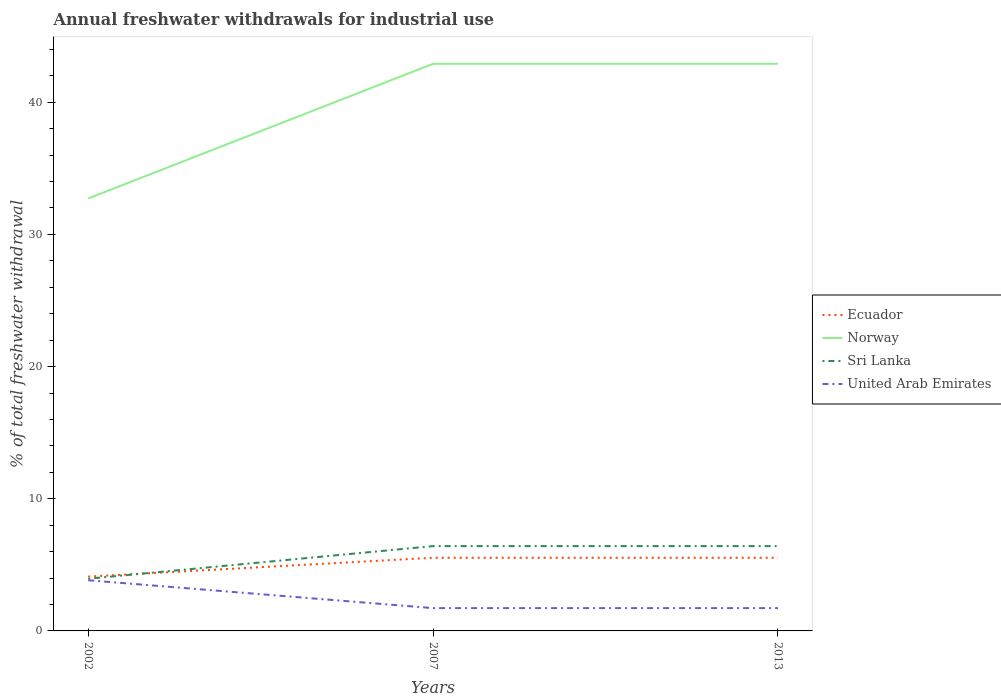How many different coloured lines are there?
Keep it short and to the point. 4. Is the number of lines equal to the number of legend labels?
Provide a short and direct response. Yes. Across all years, what is the maximum total annual withdrawals from freshwater in Norway?
Make the answer very short. 32.72. In which year was the total annual withdrawals from freshwater in Norway maximum?
Your answer should be very brief. 2002. What is the total total annual withdrawals from freshwater in Norway in the graph?
Your answer should be compact. 0. What is the difference between the highest and the second highest total annual withdrawals from freshwater in Norway?
Your response must be concise. 10.19. What is the difference between two consecutive major ticks on the Y-axis?
Keep it short and to the point. 10. Does the graph contain any zero values?
Provide a succinct answer. No. How many legend labels are there?
Provide a succinct answer. 4. How are the legend labels stacked?
Provide a succinct answer. Vertical. What is the title of the graph?
Your answer should be very brief. Annual freshwater withdrawals for industrial use. What is the label or title of the Y-axis?
Ensure brevity in your answer.  % of total freshwater withdrawal. What is the % of total freshwater withdrawal in Ecuador in 2002?
Offer a terse response. 4.11. What is the % of total freshwater withdrawal in Norway in 2002?
Ensure brevity in your answer.  32.72. What is the % of total freshwater withdrawal of Sri Lanka in 2002?
Offer a terse response. 3.95. What is the % of total freshwater withdrawal of United Arab Emirates in 2002?
Offer a terse response. 3.83. What is the % of total freshwater withdrawal of Ecuador in 2007?
Provide a short and direct response. 5.54. What is the % of total freshwater withdrawal in Norway in 2007?
Keep it short and to the point. 42.91. What is the % of total freshwater withdrawal in Sri Lanka in 2007?
Your response must be concise. 6.42. What is the % of total freshwater withdrawal of United Arab Emirates in 2007?
Make the answer very short. 1.73. What is the % of total freshwater withdrawal in Ecuador in 2013?
Offer a very short reply. 5.54. What is the % of total freshwater withdrawal of Norway in 2013?
Give a very brief answer. 42.91. What is the % of total freshwater withdrawal in Sri Lanka in 2013?
Provide a short and direct response. 6.42. What is the % of total freshwater withdrawal in United Arab Emirates in 2013?
Ensure brevity in your answer.  1.73. Across all years, what is the maximum % of total freshwater withdrawal in Ecuador?
Offer a very short reply. 5.54. Across all years, what is the maximum % of total freshwater withdrawal of Norway?
Offer a very short reply. 42.91. Across all years, what is the maximum % of total freshwater withdrawal in Sri Lanka?
Offer a very short reply. 6.42. Across all years, what is the maximum % of total freshwater withdrawal of United Arab Emirates?
Provide a succinct answer. 3.83. Across all years, what is the minimum % of total freshwater withdrawal of Ecuador?
Offer a terse response. 4.11. Across all years, what is the minimum % of total freshwater withdrawal in Norway?
Give a very brief answer. 32.72. Across all years, what is the minimum % of total freshwater withdrawal in Sri Lanka?
Provide a succinct answer. 3.95. Across all years, what is the minimum % of total freshwater withdrawal of United Arab Emirates?
Keep it short and to the point. 1.73. What is the total % of total freshwater withdrawal in Ecuador in the graph?
Ensure brevity in your answer.  15.18. What is the total % of total freshwater withdrawal of Norway in the graph?
Your response must be concise. 118.54. What is the total % of total freshwater withdrawal of Sri Lanka in the graph?
Offer a terse response. 16.78. What is the total % of total freshwater withdrawal in United Arab Emirates in the graph?
Offer a very short reply. 7.29. What is the difference between the % of total freshwater withdrawal in Ecuador in 2002 and that in 2007?
Your answer should be very brief. -1.42. What is the difference between the % of total freshwater withdrawal in Norway in 2002 and that in 2007?
Offer a terse response. -10.19. What is the difference between the % of total freshwater withdrawal of Sri Lanka in 2002 and that in 2007?
Ensure brevity in your answer.  -2.47. What is the difference between the % of total freshwater withdrawal of United Arab Emirates in 2002 and that in 2007?
Your answer should be very brief. 2.11. What is the difference between the % of total freshwater withdrawal in Ecuador in 2002 and that in 2013?
Ensure brevity in your answer.  -1.42. What is the difference between the % of total freshwater withdrawal of Norway in 2002 and that in 2013?
Ensure brevity in your answer.  -10.19. What is the difference between the % of total freshwater withdrawal in Sri Lanka in 2002 and that in 2013?
Provide a short and direct response. -2.47. What is the difference between the % of total freshwater withdrawal of United Arab Emirates in 2002 and that in 2013?
Provide a short and direct response. 2.11. What is the difference between the % of total freshwater withdrawal of Ecuador in 2007 and that in 2013?
Offer a terse response. 0. What is the difference between the % of total freshwater withdrawal of Sri Lanka in 2007 and that in 2013?
Offer a terse response. 0. What is the difference between the % of total freshwater withdrawal in Ecuador in 2002 and the % of total freshwater withdrawal in Norway in 2007?
Offer a very short reply. -38.8. What is the difference between the % of total freshwater withdrawal of Ecuador in 2002 and the % of total freshwater withdrawal of Sri Lanka in 2007?
Your answer should be compact. -2.31. What is the difference between the % of total freshwater withdrawal of Ecuador in 2002 and the % of total freshwater withdrawal of United Arab Emirates in 2007?
Give a very brief answer. 2.38. What is the difference between the % of total freshwater withdrawal in Norway in 2002 and the % of total freshwater withdrawal in Sri Lanka in 2007?
Offer a terse response. 26.3. What is the difference between the % of total freshwater withdrawal in Norway in 2002 and the % of total freshwater withdrawal in United Arab Emirates in 2007?
Your response must be concise. 30.99. What is the difference between the % of total freshwater withdrawal of Sri Lanka in 2002 and the % of total freshwater withdrawal of United Arab Emirates in 2007?
Ensure brevity in your answer.  2.22. What is the difference between the % of total freshwater withdrawal of Ecuador in 2002 and the % of total freshwater withdrawal of Norway in 2013?
Provide a succinct answer. -38.8. What is the difference between the % of total freshwater withdrawal in Ecuador in 2002 and the % of total freshwater withdrawal in Sri Lanka in 2013?
Offer a terse response. -2.31. What is the difference between the % of total freshwater withdrawal in Ecuador in 2002 and the % of total freshwater withdrawal in United Arab Emirates in 2013?
Provide a short and direct response. 2.38. What is the difference between the % of total freshwater withdrawal in Norway in 2002 and the % of total freshwater withdrawal in Sri Lanka in 2013?
Give a very brief answer. 26.3. What is the difference between the % of total freshwater withdrawal in Norway in 2002 and the % of total freshwater withdrawal in United Arab Emirates in 2013?
Offer a very short reply. 30.99. What is the difference between the % of total freshwater withdrawal of Sri Lanka in 2002 and the % of total freshwater withdrawal of United Arab Emirates in 2013?
Keep it short and to the point. 2.22. What is the difference between the % of total freshwater withdrawal in Ecuador in 2007 and the % of total freshwater withdrawal in Norway in 2013?
Ensure brevity in your answer.  -37.38. What is the difference between the % of total freshwater withdrawal of Ecuador in 2007 and the % of total freshwater withdrawal of Sri Lanka in 2013?
Make the answer very short. -0.88. What is the difference between the % of total freshwater withdrawal of Ecuador in 2007 and the % of total freshwater withdrawal of United Arab Emirates in 2013?
Keep it short and to the point. 3.81. What is the difference between the % of total freshwater withdrawal in Norway in 2007 and the % of total freshwater withdrawal in Sri Lanka in 2013?
Offer a terse response. 36.49. What is the difference between the % of total freshwater withdrawal in Norway in 2007 and the % of total freshwater withdrawal in United Arab Emirates in 2013?
Your answer should be compact. 41.18. What is the difference between the % of total freshwater withdrawal of Sri Lanka in 2007 and the % of total freshwater withdrawal of United Arab Emirates in 2013?
Your answer should be compact. 4.69. What is the average % of total freshwater withdrawal of Ecuador per year?
Offer a very short reply. 5.06. What is the average % of total freshwater withdrawal in Norway per year?
Offer a terse response. 39.51. What is the average % of total freshwater withdrawal in Sri Lanka per year?
Offer a very short reply. 5.59. What is the average % of total freshwater withdrawal in United Arab Emirates per year?
Provide a succinct answer. 2.43. In the year 2002, what is the difference between the % of total freshwater withdrawal in Ecuador and % of total freshwater withdrawal in Norway?
Offer a terse response. -28.61. In the year 2002, what is the difference between the % of total freshwater withdrawal of Ecuador and % of total freshwater withdrawal of Sri Lanka?
Offer a terse response. 0.16. In the year 2002, what is the difference between the % of total freshwater withdrawal of Ecuador and % of total freshwater withdrawal of United Arab Emirates?
Your answer should be compact. 0.28. In the year 2002, what is the difference between the % of total freshwater withdrawal in Norway and % of total freshwater withdrawal in Sri Lanka?
Your response must be concise. 28.77. In the year 2002, what is the difference between the % of total freshwater withdrawal in Norway and % of total freshwater withdrawal in United Arab Emirates?
Provide a succinct answer. 28.89. In the year 2002, what is the difference between the % of total freshwater withdrawal in Sri Lanka and % of total freshwater withdrawal in United Arab Emirates?
Offer a terse response. 0.12. In the year 2007, what is the difference between the % of total freshwater withdrawal in Ecuador and % of total freshwater withdrawal in Norway?
Your answer should be compact. -37.38. In the year 2007, what is the difference between the % of total freshwater withdrawal in Ecuador and % of total freshwater withdrawal in Sri Lanka?
Your response must be concise. -0.88. In the year 2007, what is the difference between the % of total freshwater withdrawal of Ecuador and % of total freshwater withdrawal of United Arab Emirates?
Provide a short and direct response. 3.81. In the year 2007, what is the difference between the % of total freshwater withdrawal in Norway and % of total freshwater withdrawal in Sri Lanka?
Offer a very short reply. 36.49. In the year 2007, what is the difference between the % of total freshwater withdrawal in Norway and % of total freshwater withdrawal in United Arab Emirates?
Your response must be concise. 41.18. In the year 2007, what is the difference between the % of total freshwater withdrawal in Sri Lanka and % of total freshwater withdrawal in United Arab Emirates?
Give a very brief answer. 4.69. In the year 2013, what is the difference between the % of total freshwater withdrawal in Ecuador and % of total freshwater withdrawal in Norway?
Your answer should be compact. -37.38. In the year 2013, what is the difference between the % of total freshwater withdrawal in Ecuador and % of total freshwater withdrawal in Sri Lanka?
Make the answer very short. -0.88. In the year 2013, what is the difference between the % of total freshwater withdrawal of Ecuador and % of total freshwater withdrawal of United Arab Emirates?
Provide a succinct answer. 3.81. In the year 2013, what is the difference between the % of total freshwater withdrawal in Norway and % of total freshwater withdrawal in Sri Lanka?
Provide a succinct answer. 36.49. In the year 2013, what is the difference between the % of total freshwater withdrawal in Norway and % of total freshwater withdrawal in United Arab Emirates?
Provide a succinct answer. 41.18. In the year 2013, what is the difference between the % of total freshwater withdrawal of Sri Lanka and % of total freshwater withdrawal of United Arab Emirates?
Offer a terse response. 4.69. What is the ratio of the % of total freshwater withdrawal of Ecuador in 2002 to that in 2007?
Your answer should be very brief. 0.74. What is the ratio of the % of total freshwater withdrawal of Norway in 2002 to that in 2007?
Make the answer very short. 0.76. What is the ratio of the % of total freshwater withdrawal of Sri Lanka in 2002 to that in 2007?
Keep it short and to the point. 0.62. What is the ratio of the % of total freshwater withdrawal in United Arab Emirates in 2002 to that in 2007?
Keep it short and to the point. 2.22. What is the ratio of the % of total freshwater withdrawal of Ecuador in 2002 to that in 2013?
Offer a very short reply. 0.74. What is the ratio of the % of total freshwater withdrawal of Norway in 2002 to that in 2013?
Give a very brief answer. 0.76. What is the ratio of the % of total freshwater withdrawal of Sri Lanka in 2002 to that in 2013?
Your answer should be compact. 0.62. What is the ratio of the % of total freshwater withdrawal of United Arab Emirates in 2002 to that in 2013?
Keep it short and to the point. 2.22. What is the ratio of the % of total freshwater withdrawal in Ecuador in 2007 to that in 2013?
Make the answer very short. 1. What is the ratio of the % of total freshwater withdrawal in Norway in 2007 to that in 2013?
Offer a very short reply. 1. What is the ratio of the % of total freshwater withdrawal in United Arab Emirates in 2007 to that in 2013?
Your answer should be very brief. 1. What is the difference between the highest and the second highest % of total freshwater withdrawal of Ecuador?
Provide a succinct answer. 0. What is the difference between the highest and the second highest % of total freshwater withdrawal of Norway?
Your answer should be very brief. 0. What is the difference between the highest and the second highest % of total freshwater withdrawal of Sri Lanka?
Your answer should be very brief. 0. What is the difference between the highest and the second highest % of total freshwater withdrawal of United Arab Emirates?
Keep it short and to the point. 2.11. What is the difference between the highest and the lowest % of total freshwater withdrawal of Ecuador?
Provide a succinct answer. 1.42. What is the difference between the highest and the lowest % of total freshwater withdrawal of Norway?
Provide a succinct answer. 10.19. What is the difference between the highest and the lowest % of total freshwater withdrawal of Sri Lanka?
Your answer should be compact. 2.47. What is the difference between the highest and the lowest % of total freshwater withdrawal of United Arab Emirates?
Offer a terse response. 2.11. 